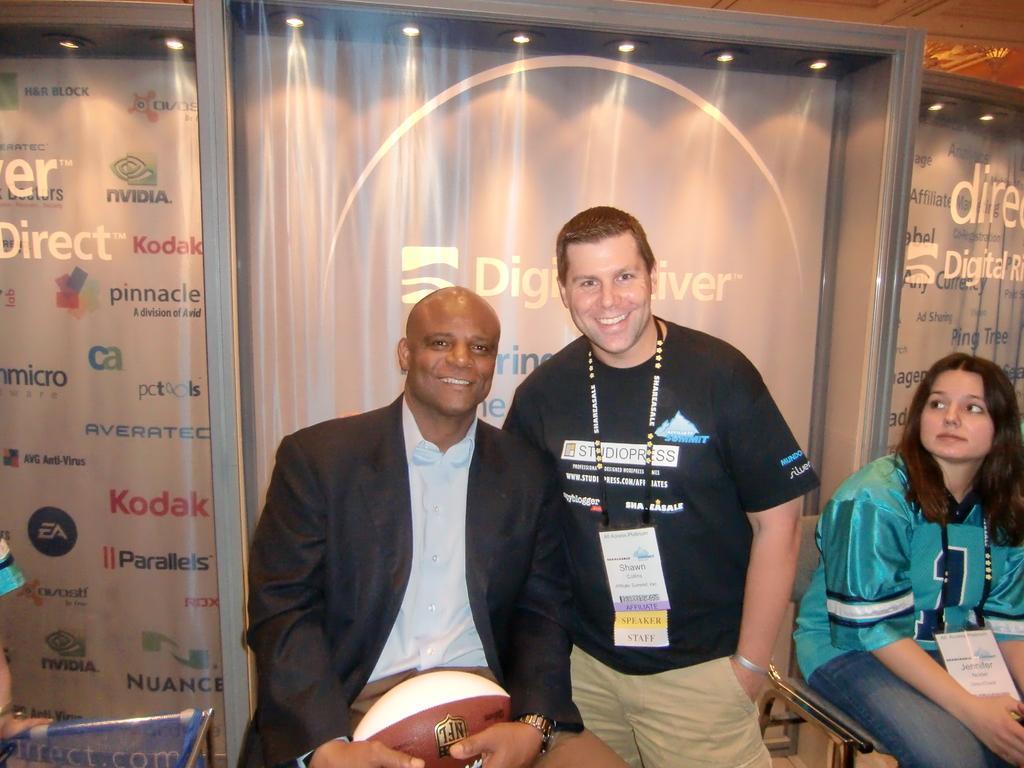Could you give a brief overview of what you see in this image? In the center of the image we can see a man is sitting and smiling and holding a ball and wearing a coat. Beside him we can see another man is standing and smiling and wearing a dress, id card. In the background of the image we can see the boards, lights. On the boards we can see the test and logos. On the right side of the image we can see a lady is sitting on a stool and wearing a dress, id card. In the bottom left corner we can see a person's hand and table. 